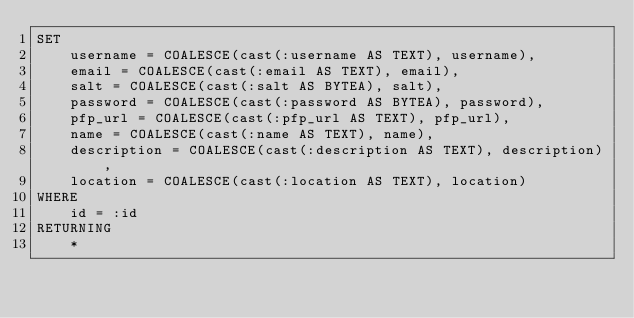<code> <loc_0><loc_0><loc_500><loc_500><_SQL_>SET
    username = COALESCE(cast(:username AS TEXT), username),
    email = COALESCE(cast(:email AS TEXT), email),
    salt = COALESCE(cast(:salt AS BYTEA), salt),
    password = COALESCE(cast(:password AS BYTEA), password),
    pfp_url = COALESCE(cast(:pfp_url AS TEXT), pfp_url),
    name = COALESCE(cast(:name AS TEXT), name),
    description = COALESCE(cast(:description AS TEXT), description),
    location = COALESCE(cast(:location AS TEXT), location)
WHERE
    id = :id
RETURNING
    *
</code> 